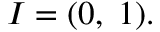Convert formula to latex. <formula><loc_0><loc_0><loc_500><loc_500>I = ( 0 , \, 1 ) .</formula> 